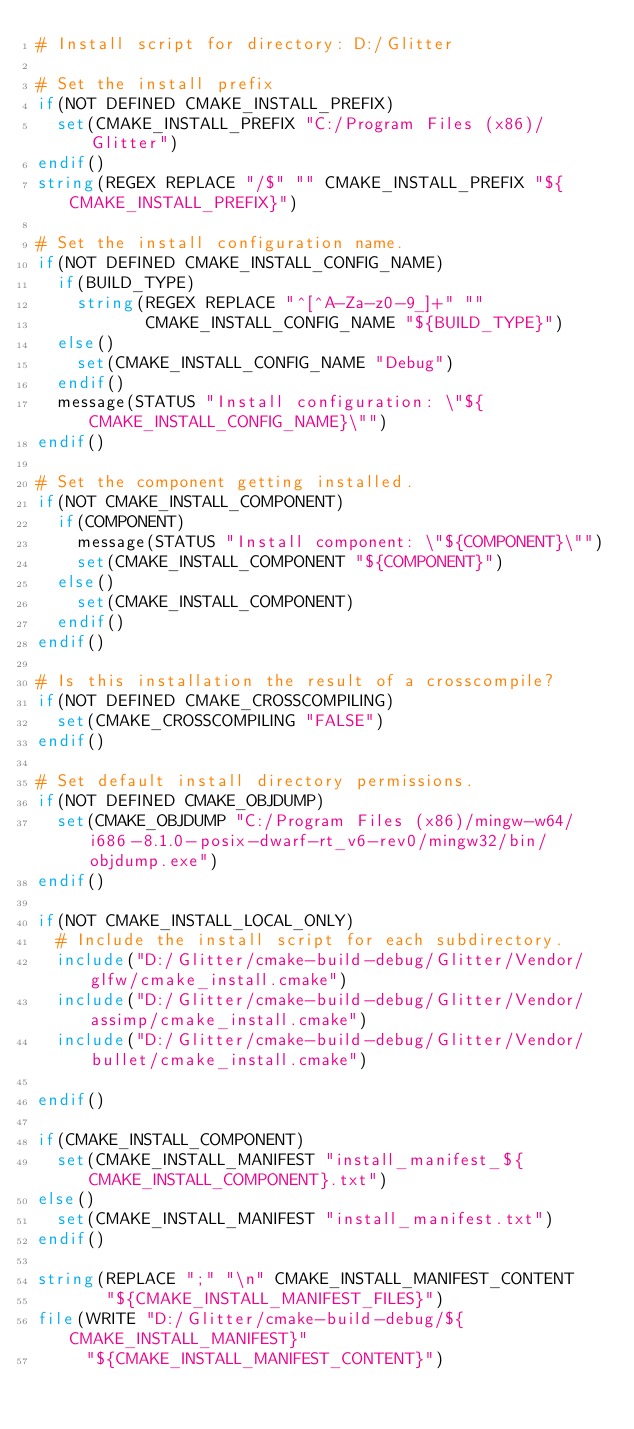<code> <loc_0><loc_0><loc_500><loc_500><_CMake_># Install script for directory: D:/Glitter

# Set the install prefix
if(NOT DEFINED CMAKE_INSTALL_PREFIX)
  set(CMAKE_INSTALL_PREFIX "C:/Program Files (x86)/Glitter")
endif()
string(REGEX REPLACE "/$" "" CMAKE_INSTALL_PREFIX "${CMAKE_INSTALL_PREFIX}")

# Set the install configuration name.
if(NOT DEFINED CMAKE_INSTALL_CONFIG_NAME)
  if(BUILD_TYPE)
    string(REGEX REPLACE "^[^A-Za-z0-9_]+" ""
           CMAKE_INSTALL_CONFIG_NAME "${BUILD_TYPE}")
  else()
    set(CMAKE_INSTALL_CONFIG_NAME "Debug")
  endif()
  message(STATUS "Install configuration: \"${CMAKE_INSTALL_CONFIG_NAME}\"")
endif()

# Set the component getting installed.
if(NOT CMAKE_INSTALL_COMPONENT)
  if(COMPONENT)
    message(STATUS "Install component: \"${COMPONENT}\"")
    set(CMAKE_INSTALL_COMPONENT "${COMPONENT}")
  else()
    set(CMAKE_INSTALL_COMPONENT)
  endif()
endif()

# Is this installation the result of a crosscompile?
if(NOT DEFINED CMAKE_CROSSCOMPILING)
  set(CMAKE_CROSSCOMPILING "FALSE")
endif()

# Set default install directory permissions.
if(NOT DEFINED CMAKE_OBJDUMP)
  set(CMAKE_OBJDUMP "C:/Program Files (x86)/mingw-w64/i686-8.1.0-posix-dwarf-rt_v6-rev0/mingw32/bin/objdump.exe")
endif()

if(NOT CMAKE_INSTALL_LOCAL_ONLY)
  # Include the install script for each subdirectory.
  include("D:/Glitter/cmake-build-debug/Glitter/Vendor/glfw/cmake_install.cmake")
  include("D:/Glitter/cmake-build-debug/Glitter/Vendor/assimp/cmake_install.cmake")
  include("D:/Glitter/cmake-build-debug/Glitter/Vendor/bullet/cmake_install.cmake")

endif()

if(CMAKE_INSTALL_COMPONENT)
  set(CMAKE_INSTALL_MANIFEST "install_manifest_${CMAKE_INSTALL_COMPONENT}.txt")
else()
  set(CMAKE_INSTALL_MANIFEST "install_manifest.txt")
endif()

string(REPLACE ";" "\n" CMAKE_INSTALL_MANIFEST_CONTENT
       "${CMAKE_INSTALL_MANIFEST_FILES}")
file(WRITE "D:/Glitter/cmake-build-debug/${CMAKE_INSTALL_MANIFEST}"
     "${CMAKE_INSTALL_MANIFEST_CONTENT}")
</code> 